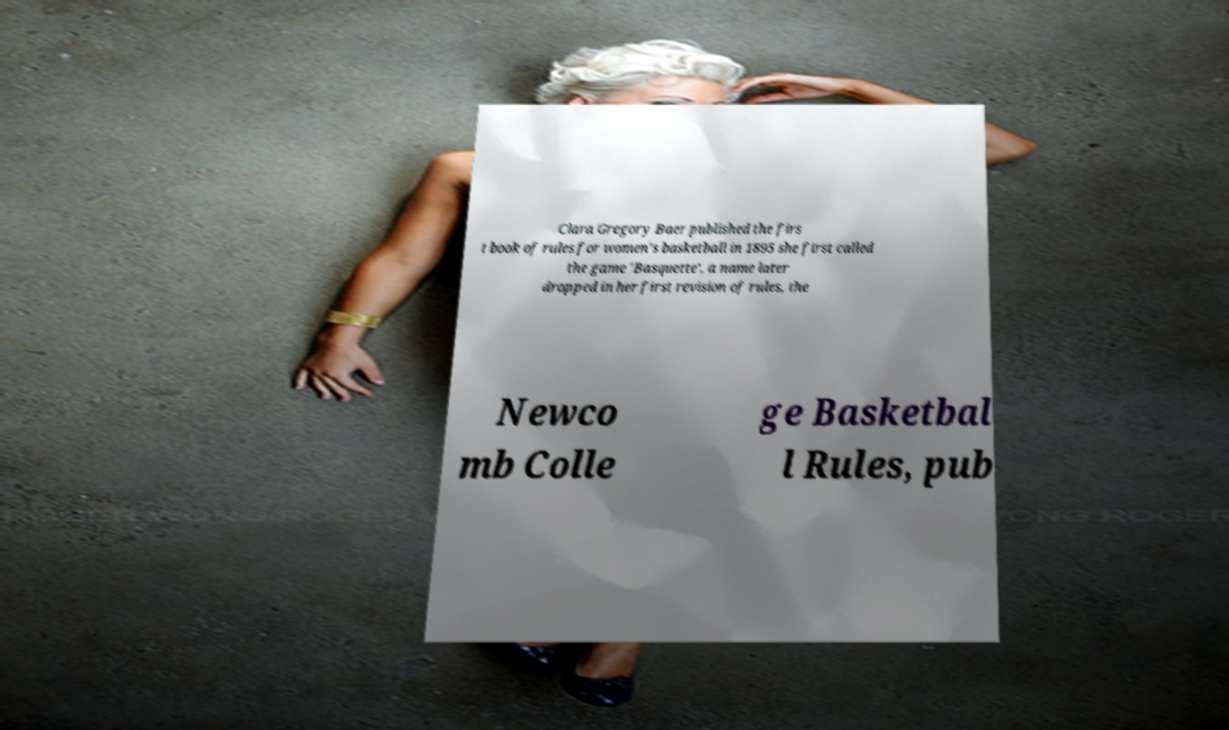Could you extract and type out the text from this image? Clara Gregory Baer published the firs t book of rules for women's basketball in 1895 she first called the game 'Basquette', a name later dropped in her first revision of rules, the Newco mb Colle ge Basketbal l Rules, pub 